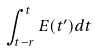Convert formula to latex. <formula><loc_0><loc_0><loc_500><loc_500>\int _ { t - r } ^ { t } E ( t ^ { \prime } ) d t</formula> 